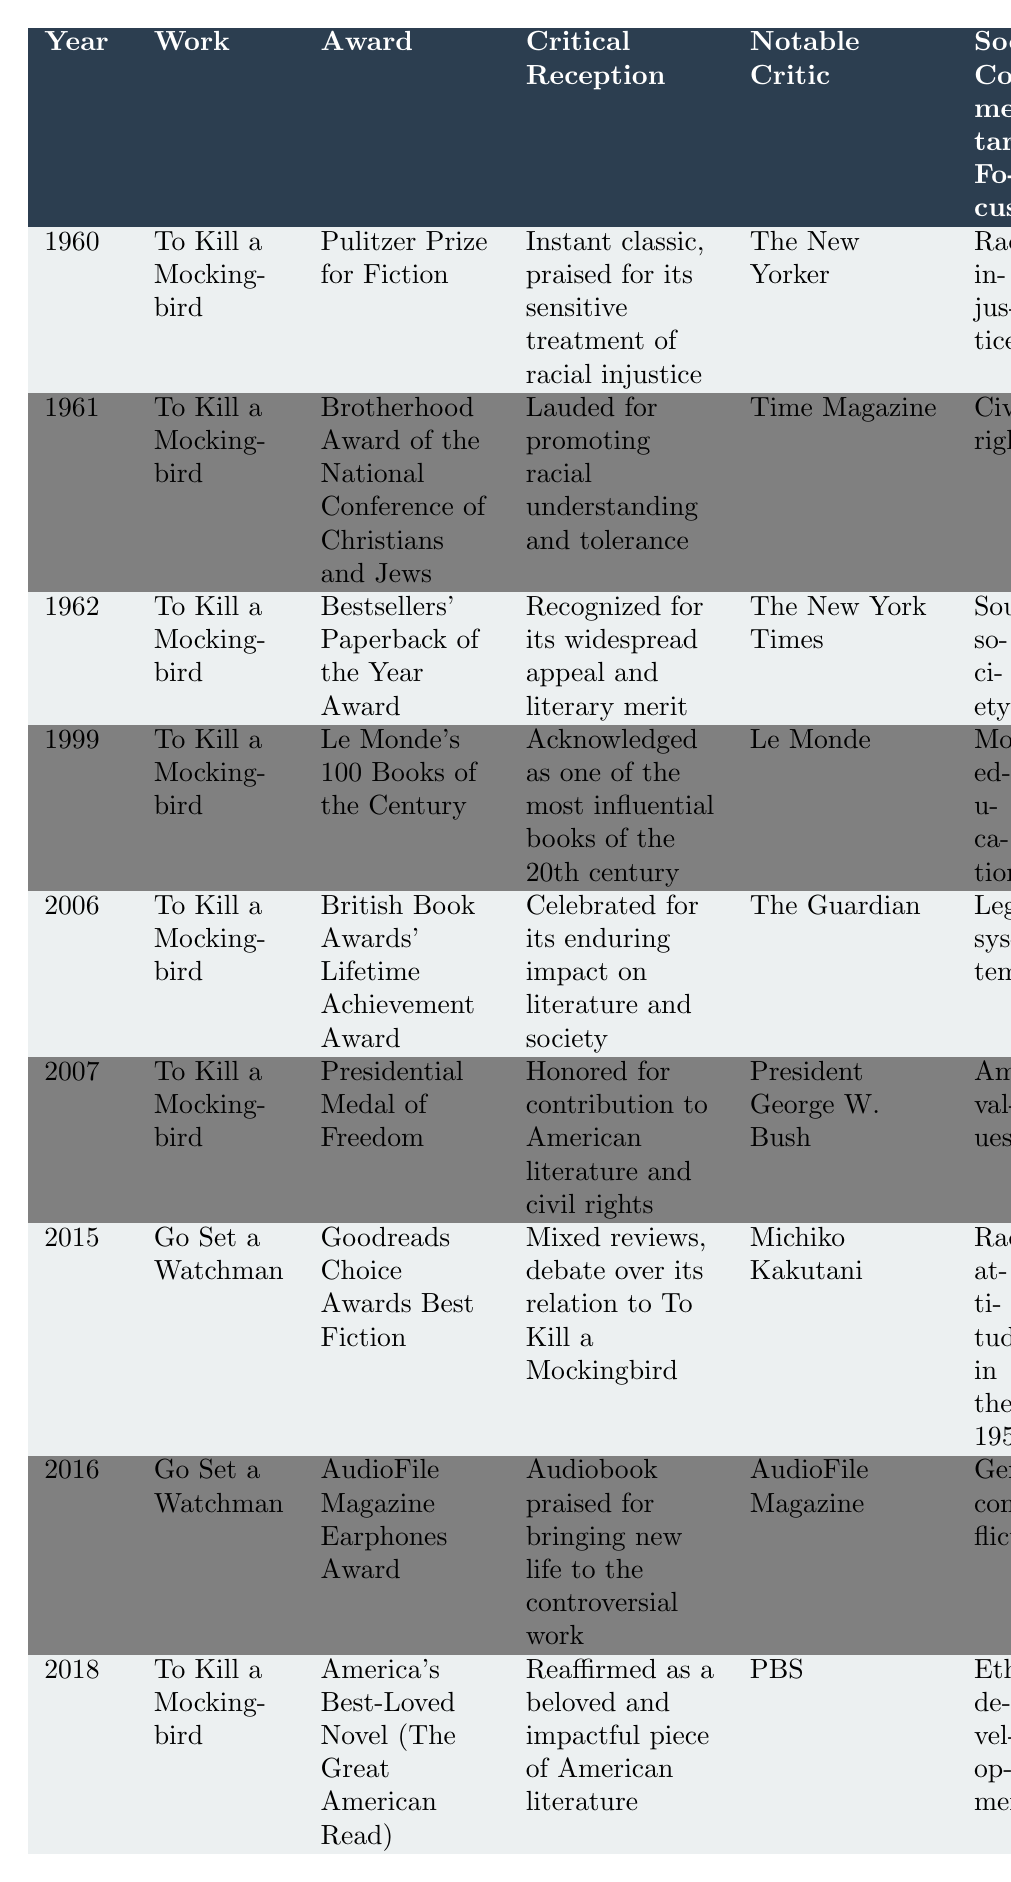What award did "To Kill a Mockingbird" win in 1960? In the table, under the year 1960 and for the work "To Kill a Mockingbird," it shows that it won the "Pulitzer Prize for Fiction."
Answer: Pulitzer Prize for Fiction Which notable critic praised "Go Set a Watchman" in 2015? Referring to the row for "Go Set a Watchman" in 2015, the notable critic listed is Michiko Kakutani.
Answer: Michiko Kakutani How many years after its initial publication did "Go Set a Watchman" receive an award? "To Kill a Mockingbird" was published in 1960. "Go Set a Watchman" was recognized in 2015. The difference between these years is 2015 - 1960, which equals 55 years.
Answer: 55 years What is the main social commentary focus highlighted in the critical reception of "To Kill a Mockingbird"? The social commentary focus listed in the table for "To Kill a Mockingbird" varies by year, but predominantly, it addresses "Racial injustice" and "Civil rights." The first mention in the table is "Racial injustice."
Answer: Racial injustice Did "To Kill a Mockingbird" receive the Presidential Medal of Freedom? In the table for 2007, it is indicated that "To Kill a Mockingbird" received the "Presidential Medal of Freedom." Thus, the statement is true.
Answer: Yes Which work had mixed reviews and debated its relationship to "To Kill a Mockingbird"? Looking at the 2015 entry for "Go Set a Watchman," it notes "Mixed reviews, debate over its relation to To Kill a Mockingbird."
Answer: Go Set a Watchman How many awards did "To Kill a Mockingbird" receive compared to "Go Set a Watchman"? "To Kill a Mockingbird" has a total of 6 entries in the awards section compared to 2 for "Go Set a Watchman" (one in 2015 and one in 2016). 6 - 2 equals 4 more awards.
Answer: 4 more awards What notable commentary was made by a notable critic about the audio version of "Go Set a Watchman"? In 2016, the table states that the audiobook of "Go Set a Watchman" was praised for bringing new life to the work, according to AudioFile Magazine.
Answer: Praised for bringing new life Which award acknowledges Harper Lee's contribution to American literature and civil rights? In the table for 2007 regarding "To Kill a Mockingbird," the award "Presidential Medal of Freedom" is mentioned, acknowledging Harper Lee's contribution.
Answer: Presidential Medal of Freedom What are the main themes discussed in the critical reception of "To Kill a Mockingbird" over the years? The table outlines various themes such as racial injustice, civil rights, and the legal system, consistently emphasizing the significance of social issues through its narrative.
Answer: Racial injustice, civil rights, legal system 